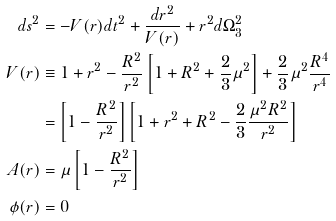Convert formula to latex. <formula><loc_0><loc_0><loc_500><loc_500>d s ^ { 2 } & = - V ( r ) d t ^ { 2 } + \frac { d r ^ { 2 } } { V ( r ) } + r ^ { 2 } d \Omega _ { 3 } ^ { 2 } \\ V ( r ) & \equiv 1 + r ^ { 2 } - \frac { R ^ { 2 } } { r ^ { 2 } } \left [ 1 + R ^ { 2 } + \frac { 2 } { 3 } \mu ^ { 2 } \right ] + \frac { 2 } { 3 } \mu ^ { 2 } \frac { R ^ { 4 } } { r ^ { 4 } } \\ & = \left [ 1 - \frac { R ^ { 2 } } { r ^ { 2 } } \right ] \left [ 1 + r ^ { 2 } + R ^ { 2 } - \frac { 2 } { 3 } \frac { \mu ^ { 2 } R ^ { 2 } } { r ^ { 2 } } \right ] \\ A ( r ) & = \mu \left [ 1 - \frac { R ^ { 2 } } { r ^ { 2 } } \right ] \\ \phi ( r ) & = 0 \\</formula> 